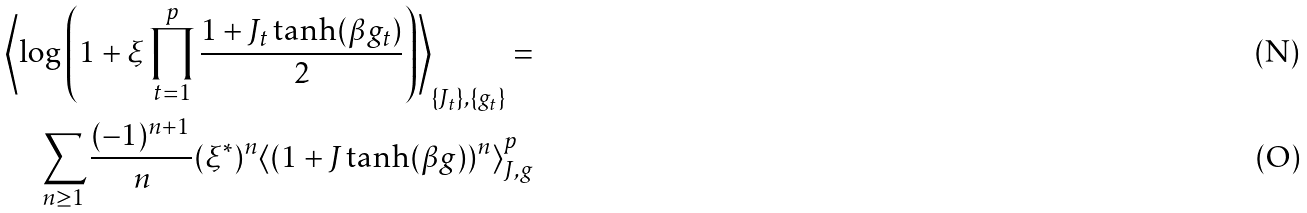Convert formula to latex. <formula><loc_0><loc_0><loc_500><loc_500>\left \langle \log \left ( 1 + \xi \prod _ { t = 1 } ^ { p } \frac { 1 + J _ { t } \tanh ( \beta g _ { t } ) } { 2 } \right ) \right \rangle _ { \{ J _ { t } \} , \{ g _ { t } \} } = \\ \sum _ { n \geq 1 } \frac { ( - 1 ) ^ { n + 1 } } { n } ( \xi ^ { * } ) ^ { n } \langle ( 1 + J \tanh ( \beta g ) ) ^ { n } \rangle _ { J , g } ^ { p }</formula> 